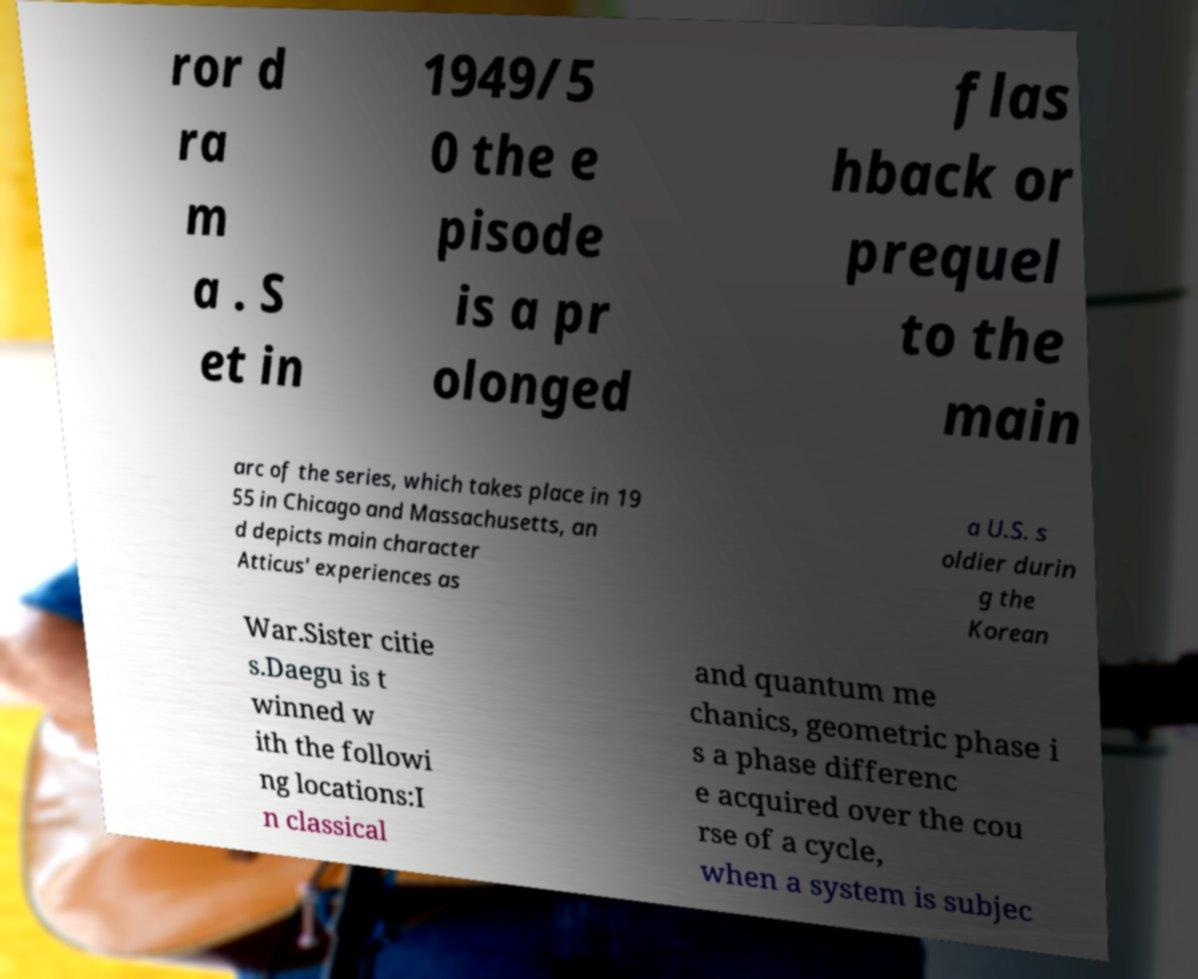Could you assist in decoding the text presented in this image and type it out clearly? ror d ra m a . S et in 1949/5 0 the e pisode is a pr olonged flas hback or prequel to the main arc of the series, which takes place in 19 55 in Chicago and Massachusetts, an d depicts main character Atticus' experiences as a U.S. s oldier durin g the Korean War.Sister citie s.Daegu is t winned w ith the followi ng locations:I n classical and quantum me chanics, geometric phase i s a phase differenc e acquired over the cou rse of a cycle, when a system is subjec 